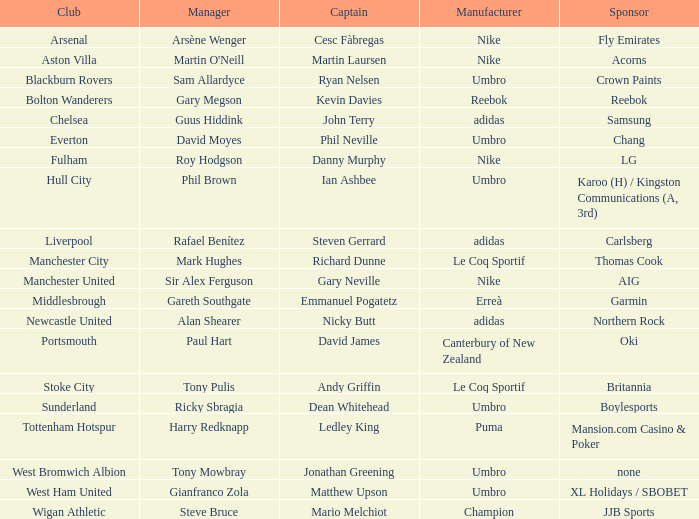In which organization is ledley king a leader? Tottenham Hotspur. 